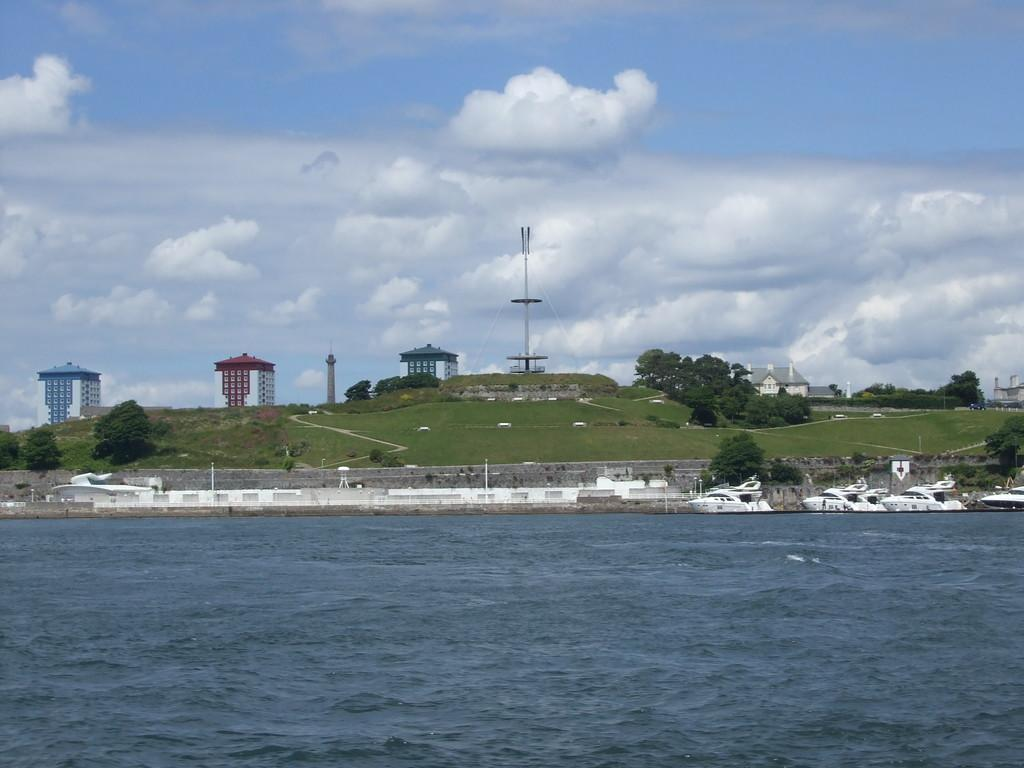What is the main feature of the image? There is water in the image. What can be seen in the water? There are boats in the water. What type of vegetation is present in the image? There is grass and trees in the image. What type of structures are visible in the image? There are buildings in the image. What is visible in the background of the image? The sky is visible in the background of the image. What type of scarecrow can be seen in the image? There is no scarecrow present in the image. What meal is being prepared in the image? There is no meal preparation visible in the image. 